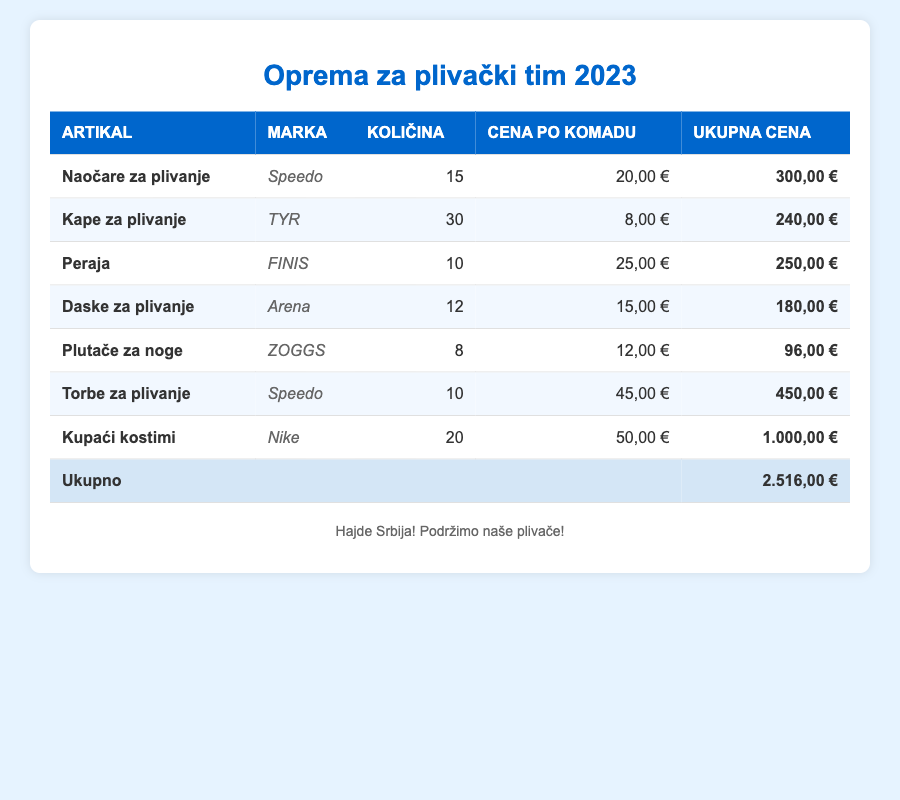What is the total cost of all equipment purchases? To find the total cost, we add all the total costs listed in the table: 300 + 240 + 250 + 180 + 96 + 450 + 1000 = 2516.
Answer: 2516,00 € How many Swim Caps were purchased? The table lists the quantity of Swim Caps as 30.
Answer: 30 Which item has the highest total cost? The highest total cost can be determined by examining the last column. Swim Suits, with a total cost of 1000, is the highest.
Answer: Swim Suits Is the total cost of the Swim Bags greater than the total cost of the Swim Fins? The total cost of Swim Bags is 450, and for Swim Fins, it is 250. Since 450 is greater than 250, the answer is yes.
Answer: Yes What is the average price per item for the equipment purchases? To calculate the average price per item, first find the total number of items purchased: 15 + 30 + 10 + 12 + 8 + 10 + 20 = 105. Then divide the total cost (2516) by the total quantity (105): 2516 / 105 = approximately 23.96.
Answer: 23.96 How much cost difference is there between Swim Suits and Swim Caps? The total cost of Swim Suits is 1000 and Swim Caps is 240. The difference is 1000 - 240 = 760.
Answer: 760,00 € Are there more Swim Goggles or Kickboards purchased? The quantity of Swim Goggles is 15 and for Kickboards, it is 12. Since 15 is greater than 12, the answer is yes.
Answer: Yes What is the total quantity of all fins and kickboards combined? The total quantity of Swim Fins is 10 and Kickboards is 12. Adding them gives 10 + 12 = 22.
Answer: 22 If every team member received a Swim Cap, how many members could receive one? Since 30 Swim Caps were purchased, it means up to 30 members could each receive one.
Answer: 30 What percentage of the total cost is spent on Swim Suits? The total cost of Swim Suits is 1000, and the total overall is 2516. The percentage is (1000 / 2516) * 100 ≈ 39.7%.
Answer: 39.7% 